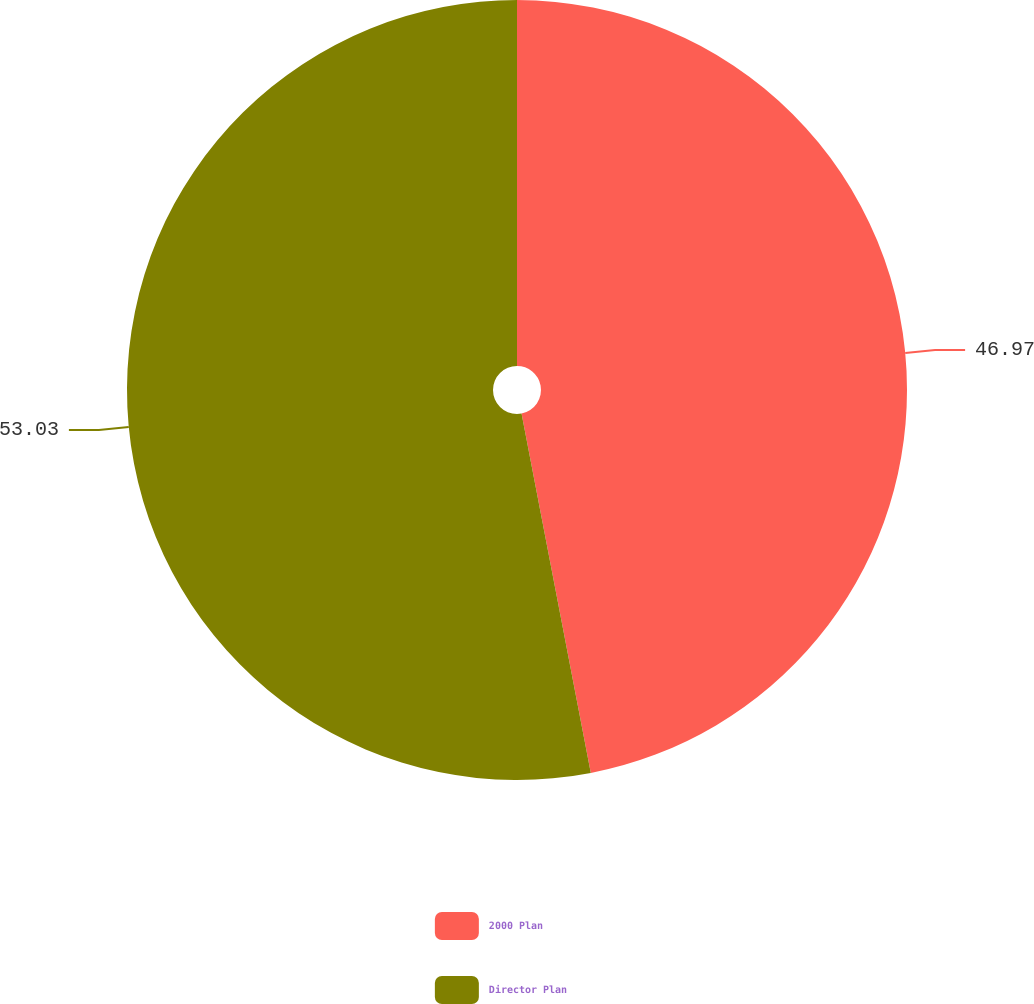Convert chart to OTSL. <chart><loc_0><loc_0><loc_500><loc_500><pie_chart><fcel>2000 Plan<fcel>Director Plan<nl><fcel>46.97%<fcel>53.03%<nl></chart> 